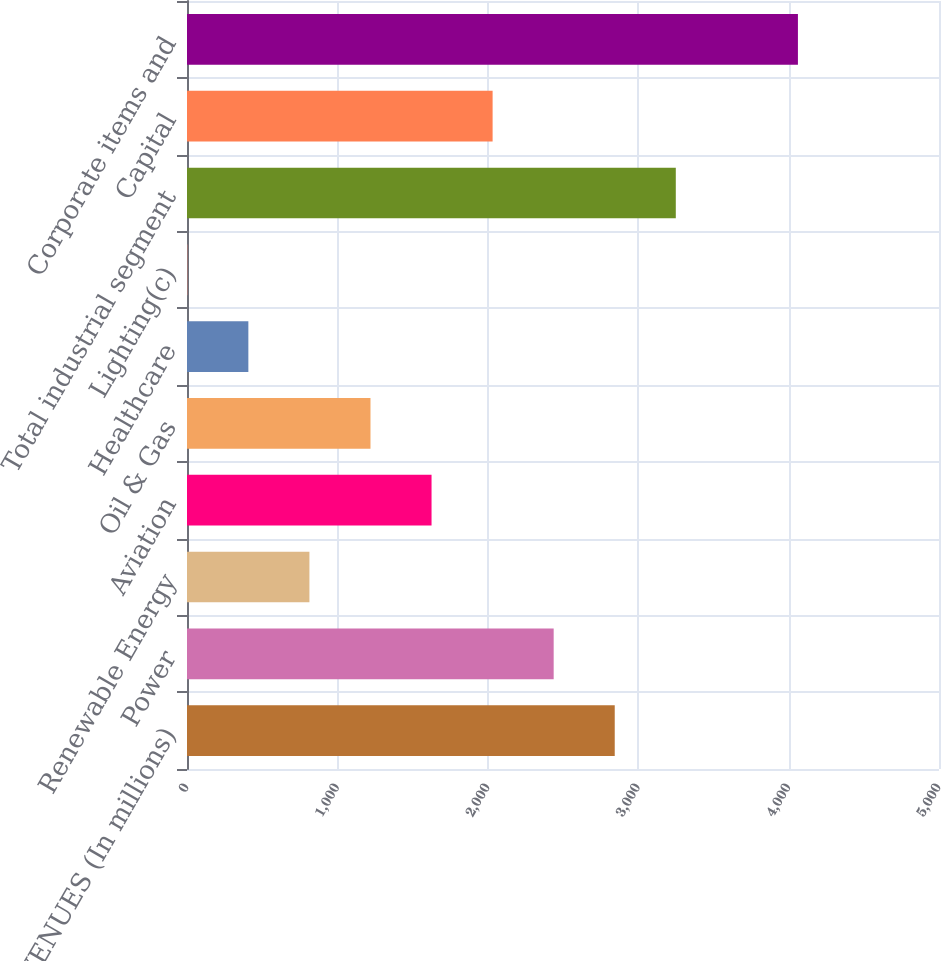Convert chart to OTSL. <chart><loc_0><loc_0><loc_500><loc_500><bar_chart><fcel>REVENUES (In millions)<fcel>Power<fcel>Renewable Energy<fcel>Aviation<fcel>Oil & Gas<fcel>Healthcare<fcel>Lighting(c)<fcel>Total industrial segment<fcel>Capital<fcel>Corporate items and<nl><fcel>2844<fcel>2438<fcel>814<fcel>1626<fcel>1220<fcel>408<fcel>2<fcel>3250<fcel>2032<fcel>4062<nl></chart> 